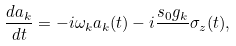Convert formula to latex. <formula><loc_0><loc_0><loc_500><loc_500>\frac { d a _ { k } } { d t } = - i \omega _ { k } a _ { k } ( t ) - i \frac { s _ { 0 } g _ { k } } { } \sigma _ { z } ( t ) ,</formula> 